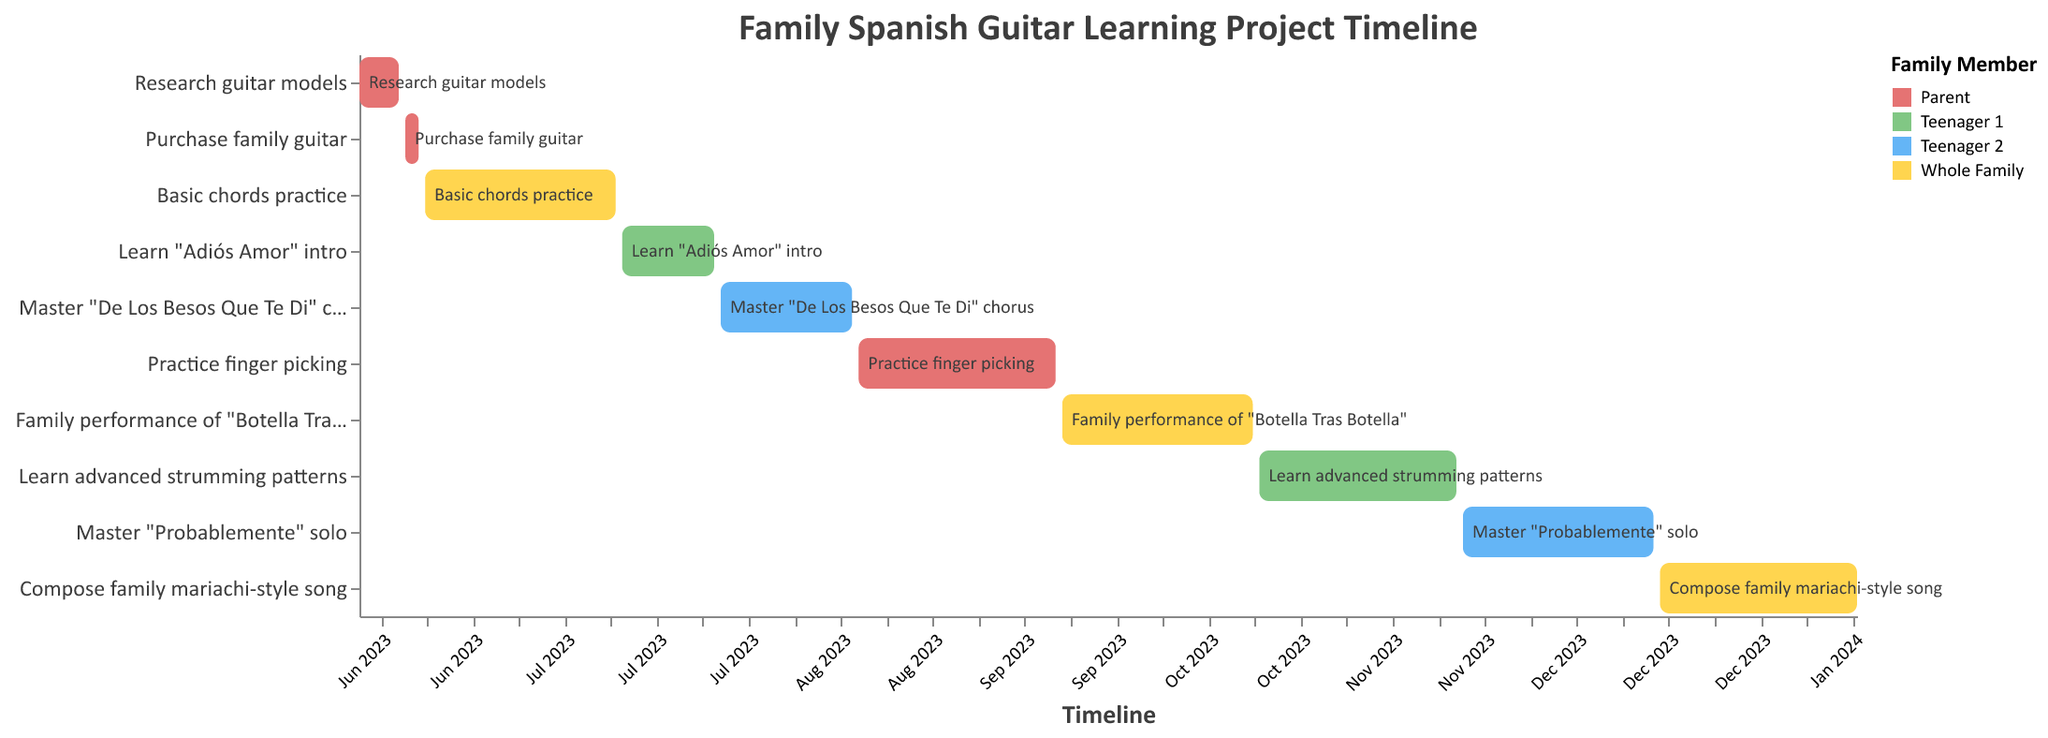What's the title of the figure? The title of the figure is displayed at the top, which provides a summary of what the chart represents.
Answer: Family Spanish Guitar Learning Project Timeline Which task is assigned to "Teenager 1" after learning the "Adiós Amor" intro? We look for tasks assigned to "Teenager 1" after the starting date of "Learn 'Adiós Amor' intro", which ends on 2023-07-25. The next task is "Learn advanced strumming patterns".
Answer: Learn advanced strumming patterns How many tasks are assigned to the whole family? We count the number of tasks where the assignee is listed as "Whole Family".
Answer: 3 What is the total duration of the "Practice finger picking" task? The "Practice finger picking" task starts on 2023-08-16 and ends on 2023-09-15. The total duration is the difference from the start date to the end date.
Answer: 30 days Which task has the shortest duration and who is assigned to it? We compare the durations of all tasks by calculating the difference between the start and end dates. The shortest duration task is "Purchase family guitar".
Answer: Purchase family guitar, Parent During which dates is the task "Master 'De Los Besos Que Te Di' chorus" scheduled? The dates for "Master 'De Los Besos Que Te Di' chorus" are given in the chart. It starts on 2023-07-26 and ends on 2023-08-15.
Answer: 2023-07-26 to 2023-08-15 What is the sequence of tasks assigned to "Teenager 2"? We find the tasks assigned to "Teenager 2" and list them in chronological order based on their start dates.
Answer: Master "De Los Besos Que Te Di" chorus, Master "Probablemente" solo When does the task "Compose family mariachi-style song" begin and end? We look for the task named "Compose family mariachi-style song" and note its start and end dates from the chart.
Answer: It begins on 2023-12-16 and ends on 2024-01-15 Which family member is responsible for the task scheduled immediately after "Learning basic chords"? We identify the end date of "Basic chords practice" (2023-07-10) and find the task that starts immediately after. The task "Learn 'Adiós Amor' intro" begins on 2023-07-11 and is assigned to "Teenager 1".
Answer: Teenager 1 How many tasks in total are included in the project timeline? We count the total number of tasks listed in the chart.
Answer: 10 